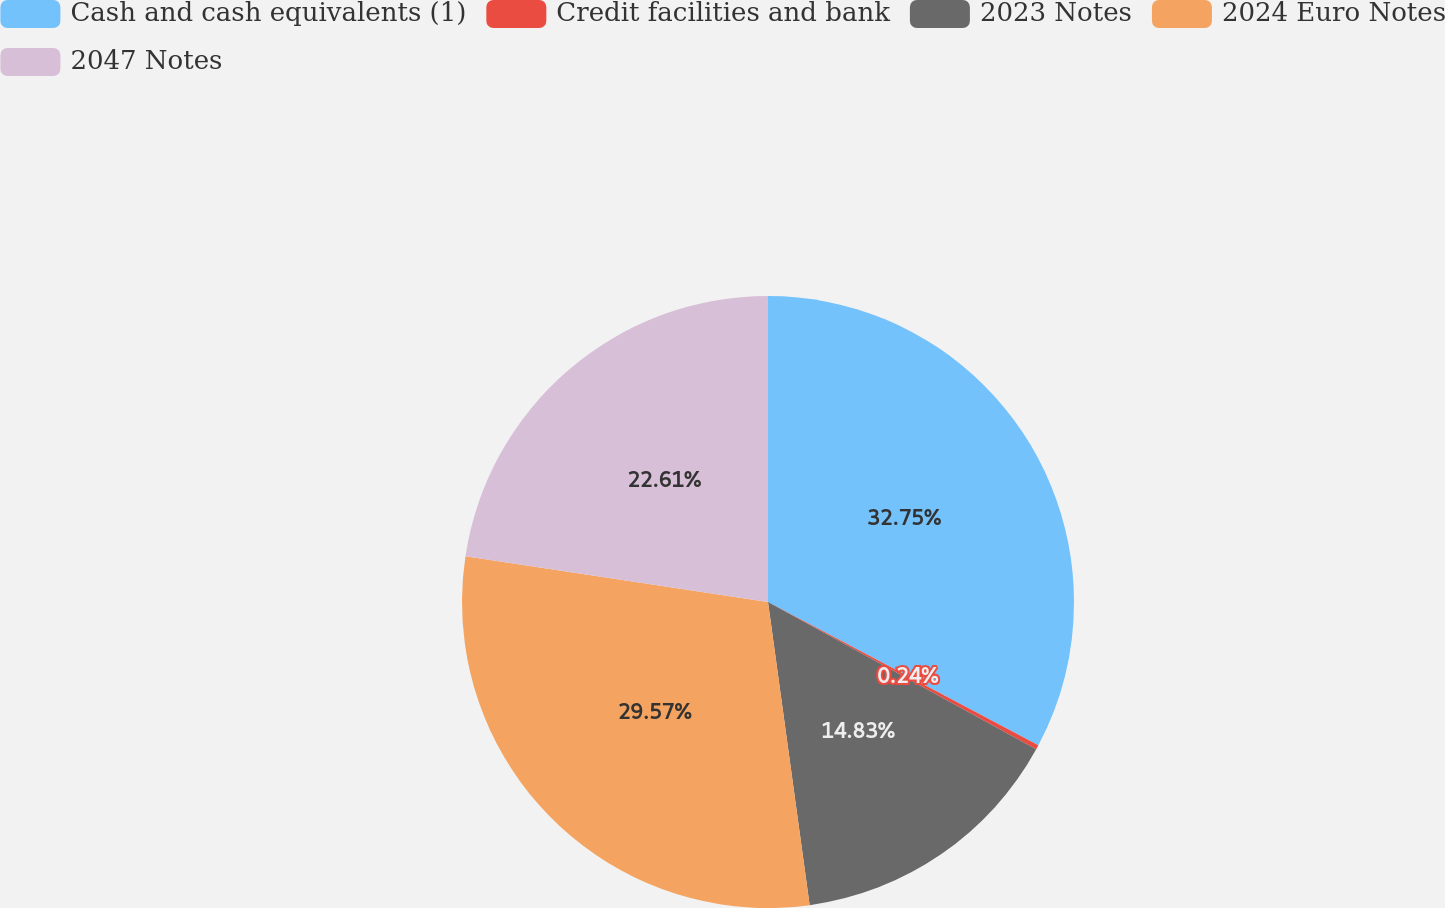Convert chart. <chart><loc_0><loc_0><loc_500><loc_500><pie_chart><fcel>Cash and cash equivalents (1)<fcel>Credit facilities and bank<fcel>2023 Notes<fcel>2024 Euro Notes<fcel>2047 Notes<nl><fcel>32.76%<fcel>0.24%<fcel>14.83%<fcel>29.57%<fcel>22.61%<nl></chart> 